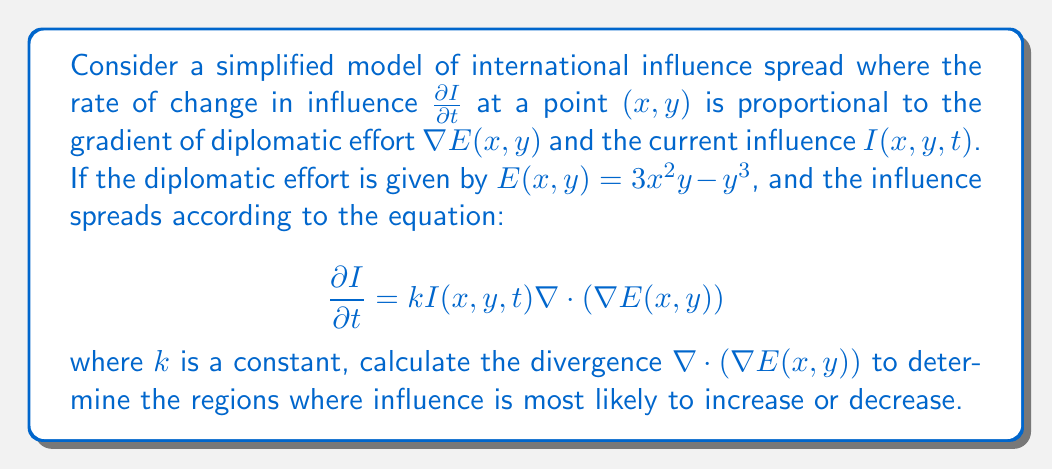Teach me how to tackle this problem. To solve this problem, we'll follow these steps:

1) First, we need to calculate $\nabla E(x,y)$. The gradient is given by:

   $$\nabla E(x,y) = \left(\frac{\partial E}{\partial x}, \frac{\partial E}{\partial y}\right)$$

2) Calculate the partial derivatives:
   
   $$\frac{\partial E}{\partial x} = 6xy$$
   $$\frac{\partial E}{\partial y} = 3x^2 - 3y^2$$

3) Therefore, $\nabla E(x,y) = (6xy, 3x^2 - 3y^2)$

4) Now, we need to calculate the divergence of this vector field:

   $$\nabla \cdot (\nabla E(x,y)) = \frac{\partial}{\partial x}(6xy) + \frac{\partial}{\partial y}(3x^2 - 3y^2)$$

5) Calculate these partial derivatives:

   $$\frac{\partial}{\partial x}(6xy) = 6y$$
   $$\frac{\partial}{\partial y}(3x^2 - 3y^2) = -6y$$

6) Sum these results:

   $$\nabla \cdot (\nabla E(x,y)) = 6y - 6y = 0$$

7) Interpret the result: The divergence is zero everywhere, which means that the influence neither consistently increases nor decreases in any region. The spread of influence is conserved throughout the space.
Answer: $\nabla \cdot (\nabla E(x,y)) = 0$ 